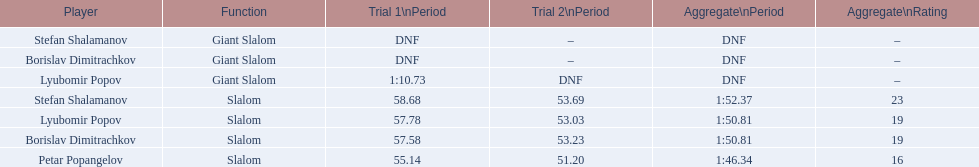Which athletes had consecutive times under 58 for both races? Lyubomir Popov, Borislav Dimitrachkov, Petar Popangelov. 